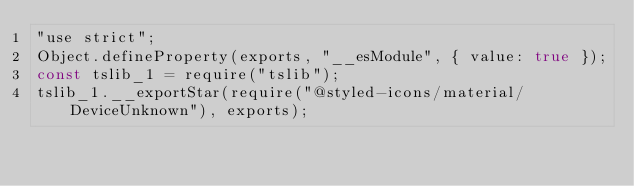Convert code to text. <code><loc_0><loc_0><loc_500><loc_500><_JavaScript_>"use strict";
Object.defineProperty(exports, "__esModule", { value: true });
const tslib_1 = require("tslib");
tslib_1.__exportStar(require("@styled-icons/material/DeviceUnknown"), exports);
</code> 